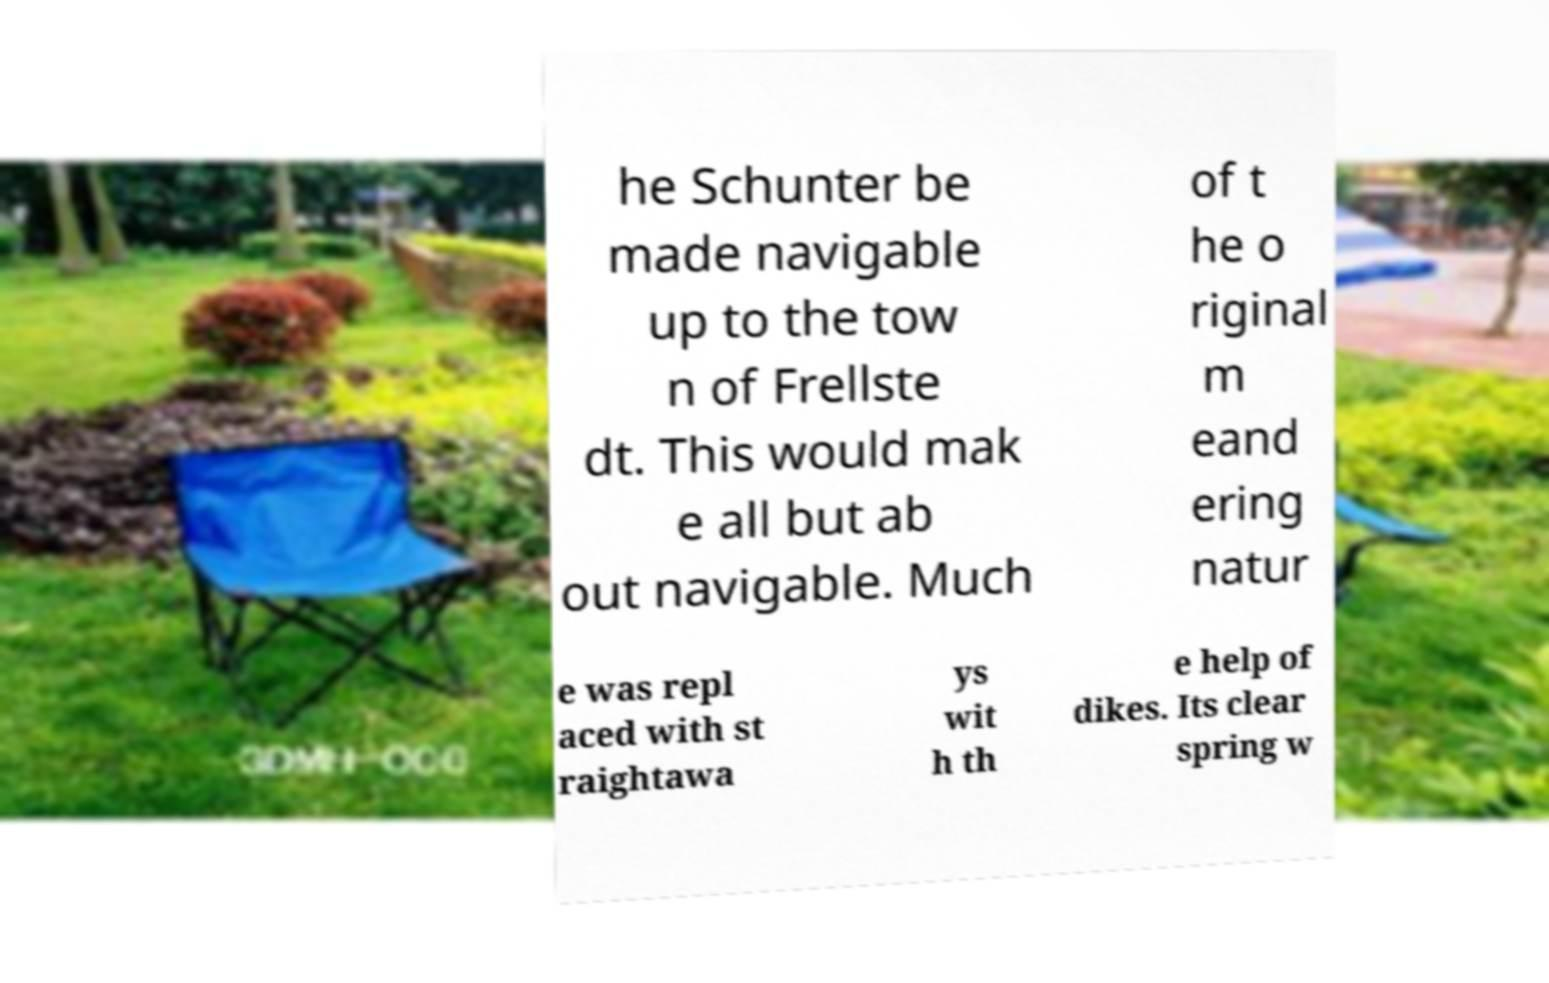Please identify and transcribe the text found in this image. he Schunter be made navigable up to the tow n of Frellste dt. This would mak e all but ab out navigable. Much of t he o riginal m eand ering natur e was repl aced with st raightawa ys wit h th e help of dikes. Its clear spring w 